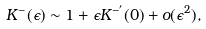Convert formula to latex. <formula><loc_0><loc_0><loc_500><loc_500>K ^ { - } ( \epsilon ) \sim 1 + \epsilon K ^ { - ^ { \prime } } ( 0 ) + o ( \epsilon ^ { 2 } ) ,</formula> 